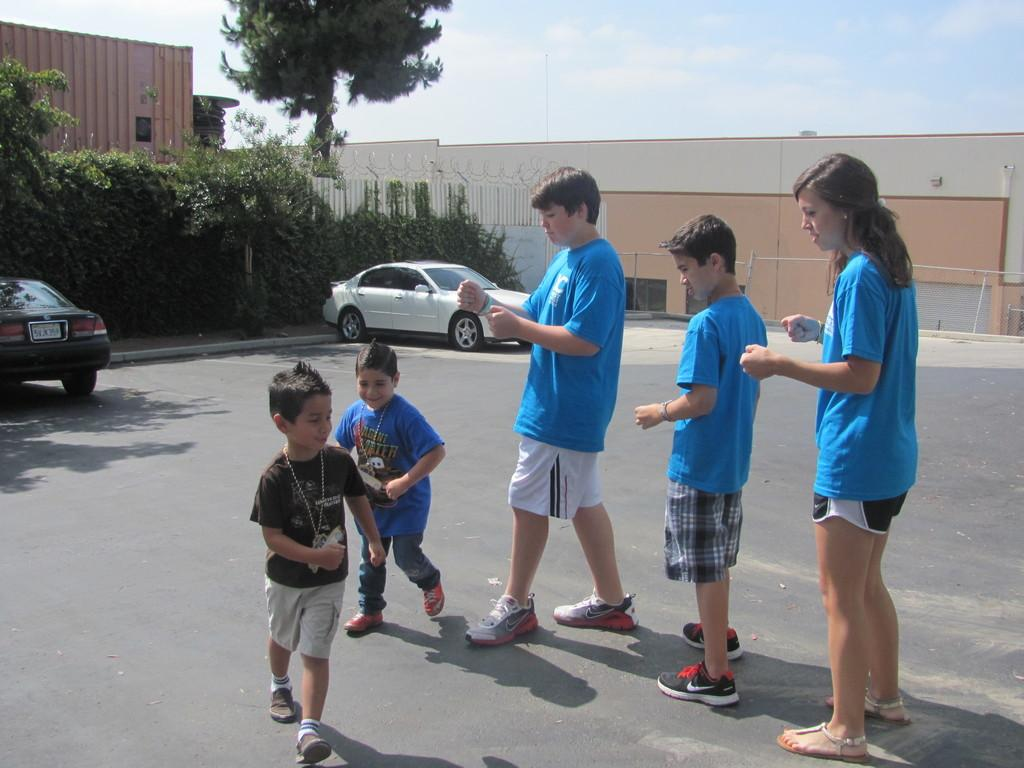What are the people in the image doing? The people in the image are playing on the road. What can be seen in the background of the image? In the background, there are cars, plants, a tree, railings, a wall, windows, a container, and the sky. Can you describe the setting of the image? The image is set on a road with various background elements, including buildings and natural features. What type of news can be heard coming from the gate in the image? There is no gate present in the image, and therefore no news can be heard coming from it. 